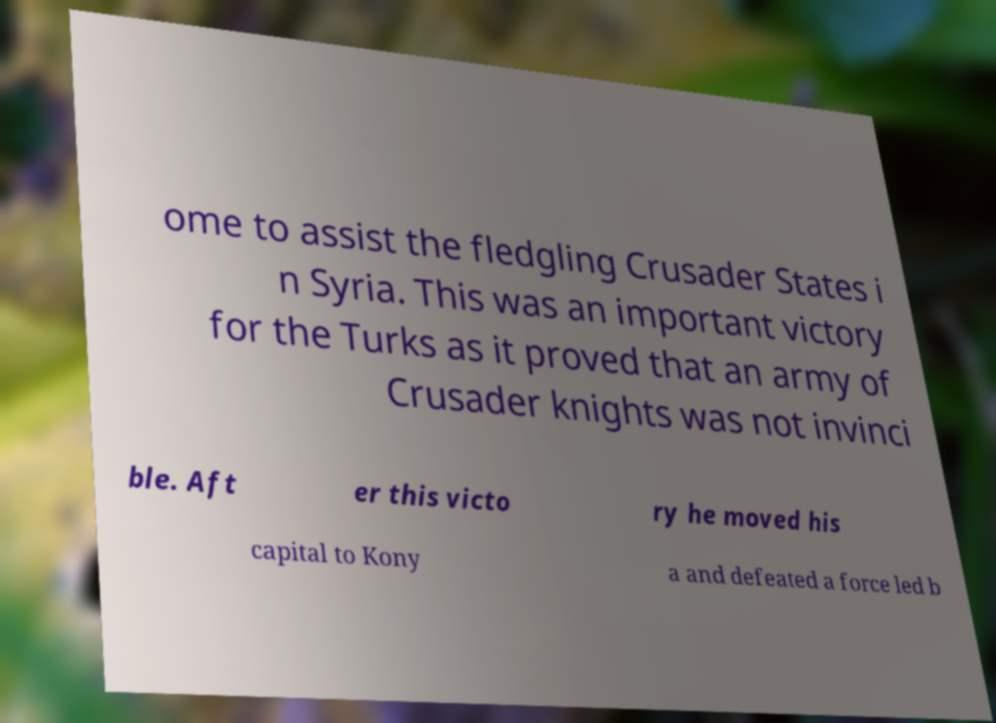Could you extract and type out the text from this image? ome to assist the fledgling Crusader States i n Syria. This was an important victory for the Turks as it proved that an army of Crusader knights was not invinci ble. Aft er this victo ry he moved his capital to Kony a and defeated a force led b 